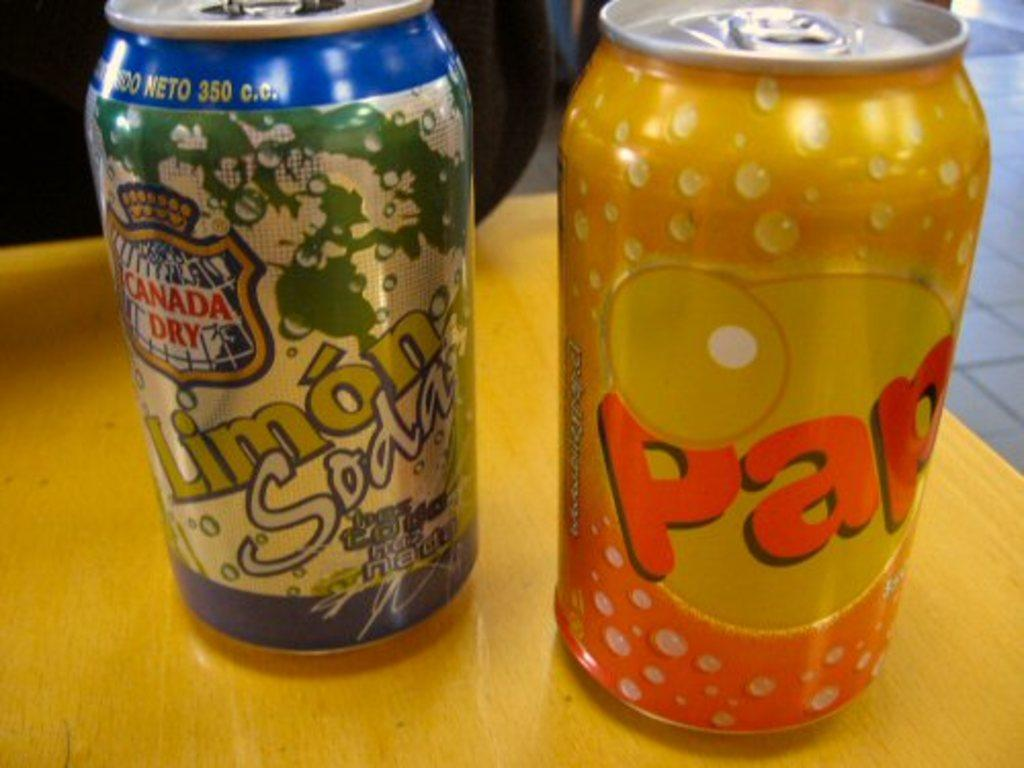<image>
Offer a succinct explanation of the picture presented. A can of Canada Dry soda is next to an orange can. 